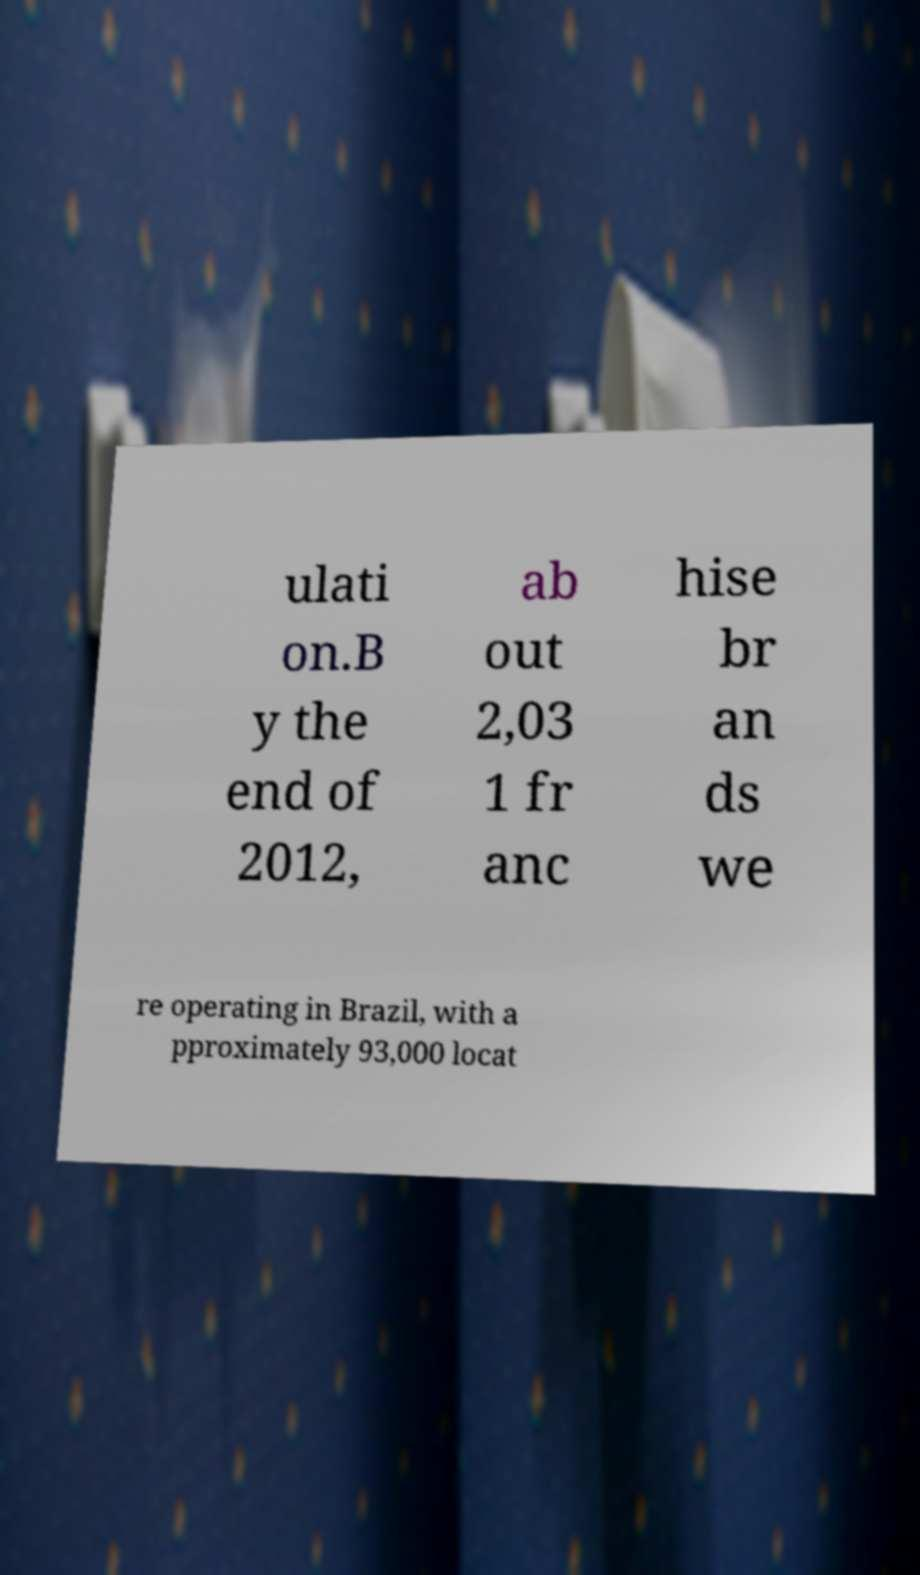For documentation purposes, I need the text within this image transcribed. Could you provide that? ulati on.B y the end of 2012, ab out 2,03 1 fr anc hise br an ds we re operating in Brazil, with a pproximately 93,000 locat 